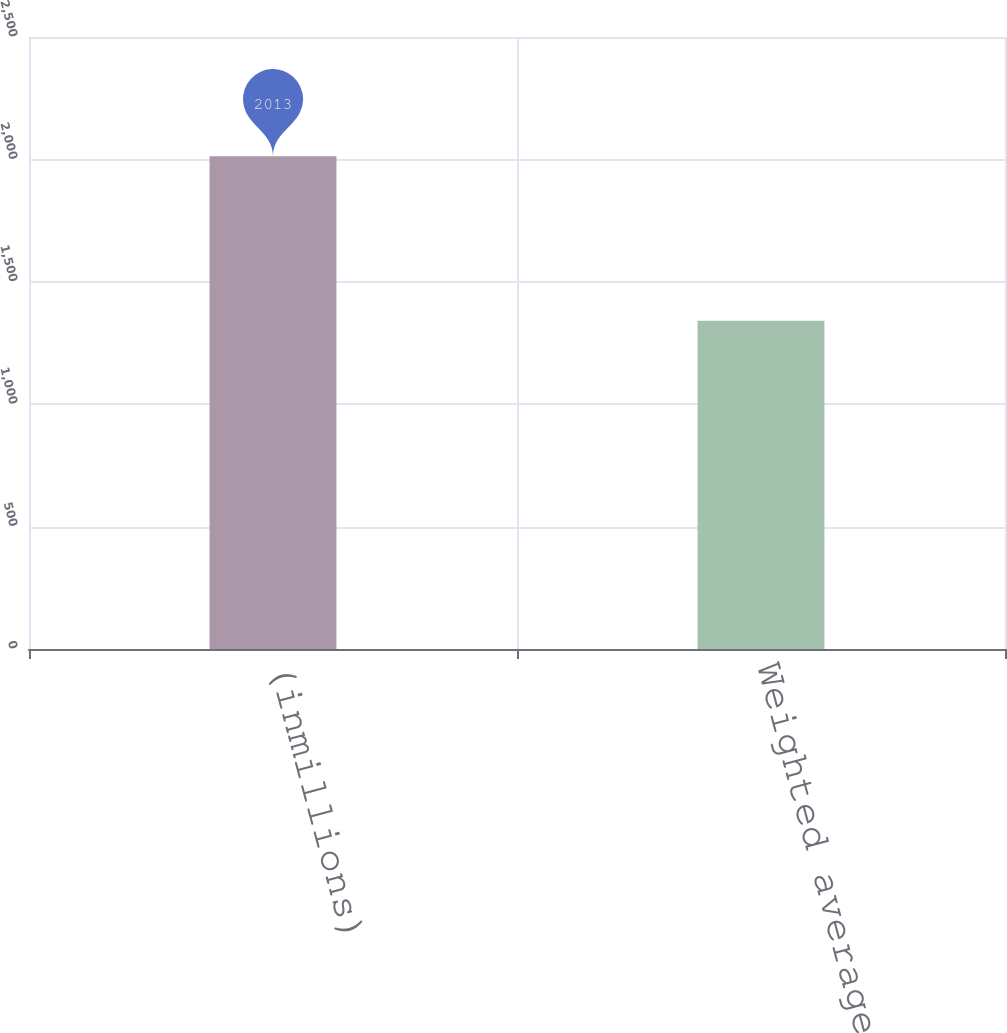Convert chart to OTSL. <chart><loc_0><loc_0><loc_500><loc_500><bar_chart><fcel>(inmillions)<fcel>Weighted average shares<nl><fcel>2013<fcel>1341.2<nl></chart> 